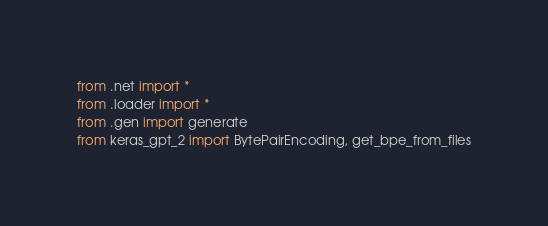<code> <loc_0><loc_0><loc_500><loc_500><_Python_>from .net import *
from .loader import *
from .gen import generate
from keras_gpt_2 import BytePairEncoding, get_bpe_from_files
</code> 